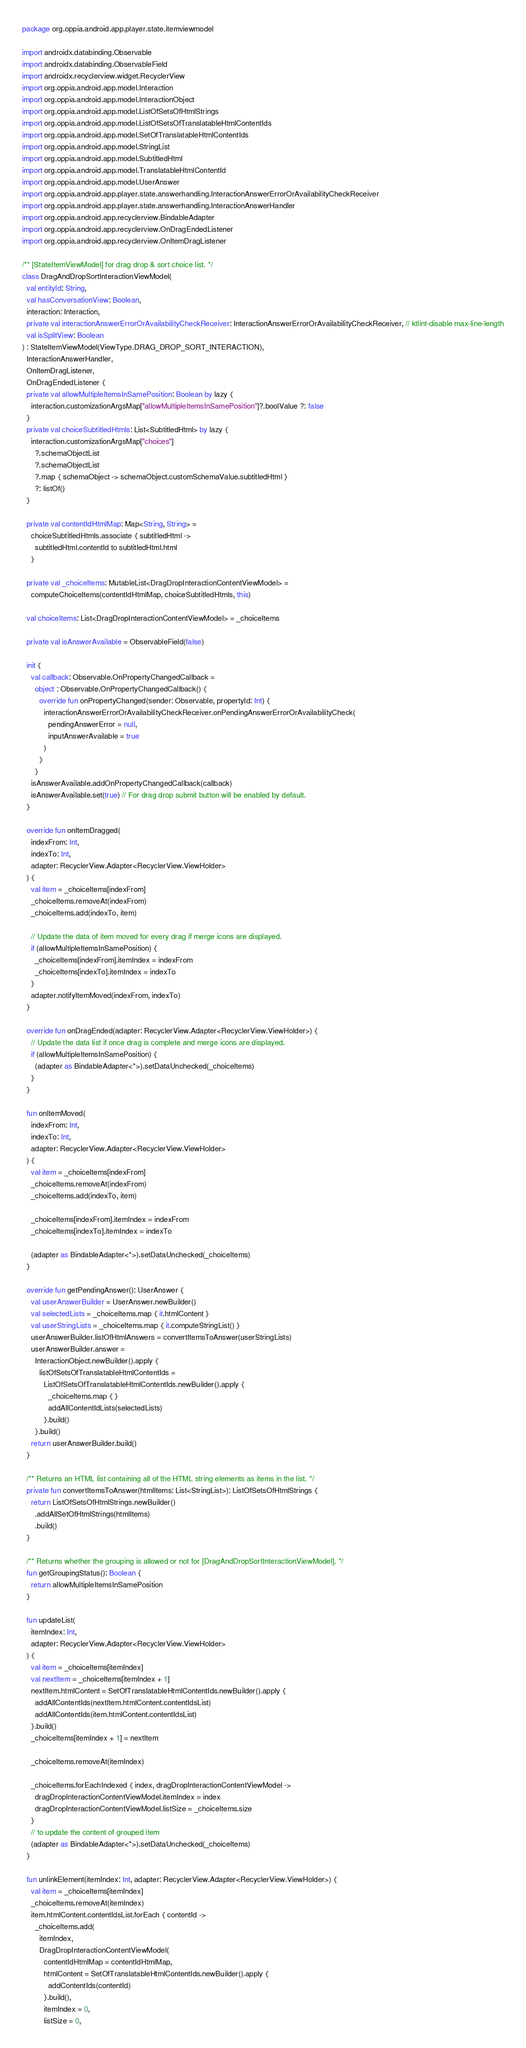Convert code to text. <code><loc_0><loc_0><loc_500><loc_500><_Kotlin_>package org.oppia.android.app.player.state.itemviewmodel

import androidx.databinding.Observable
import androidx.databinding.ObservableField
import androidx.recyclerview.widget.RecyclerView
import org.oppia.android.app.model.Interaction
import org.oppia.android.app.model.InteractionObject
import org.oppia.android.app.model.ListOfSetsOfHtmlStrings
import org.oppia.android.app.model.ListOfSetsOfTranslatableHtmlContentIds
import org.oppia.android.app.model.SetOfTranslatableHtmlContentIds
import org.oppia.android.app.model.StringList
import org.oppia.android.app.model.SubtitledHtml
import org.oppia.android.app.model.TranslatableHtmlContentId
import org.oppia.android.app.model.UserAnswer
import org.oppia.android.app.player.state.answerhandling.InteractionAnswerErrorOrAvailabilityCheckReceiver
import org.oppia.android.app.player.state.answerhandling.InteractionAnswerHandler
import org.oppia.android.app.recyclerview.BindableAdapter
import org.oppia.android.app.recyclerview.OnDragEndedListener
import org.oppia.android.app.recyclerview.OnItemDragListener

/** [StateItemViewModel] for drag drop & sort choice list. */
class DragAndDropSortInteractionViewModel(
  val entityId: String,
  val hasConversationView: Boolean,
  interaction: Interaction,
  private val interactionAnswerErrorOrAvailabilityCheckReceiver: InteractionAnswerErrorOrAvailabilityCheckReceiver, // ktlint-disable max-line-length
  val isSplitView: Boolean
) : StateItemViewModel(ViewType.DRAG_DROP_SORT_INTERACTION),
  InteractionAnswerHandler,
  OnItemDragListener,
  OnDragEndedListener {
  private val allowMultipleItemsInSamePosition: Boolean by lazy {
    interaction.customizationArgsMap["allowMultipleItemsInSamePosition"]?.boolValue ?: false
  }
  private val choiceSubtitledHtmls: List<SubtitledHtml> by lazy {
    interaction.customizationArgsMap["choices"]
      ?.schemaObjectList
      ?.schemaObjectList
      ?.map { schemaObject -> schemaObject.customSchemaValue.subtitledHtml }
      ?: listOf()
  }

  private val contentIdHtmlMap: Map<String, String> =
    choiceSubtitledHtmls.associate { subtitledHtml ->
      subtitledHtml.contentId to subtitledHtml.html
    }

  private val _choiceItems: MutableList<DragDropInteractionContentViewModel> =
    computeChoiceItems(contentIdHtmlMap, choiceSubtitledHtmls, this)

  val choiceItems: List<DragDropInteractionContentViewModel> = _choiceItems

  private val isAnswerAvailable = ObservableField(false)

  init {
    val callback: Observable.OnPropertyChangedCallback =
      object : Observable.OnPropertyChangedCallback() {
        override fun onPropertyChanged(sender: Observable, propertyId: Int) {
          interactionAnswerErrorOrAvailabilityCheckReceiver.onPendingAnswerErrorOrAvailabilityCheck(
            pendingAnswerError = null,
            inputAnswerAvailable = true
          )
        }
      }
    isAnswerAvailable.addOnPropertyChangedCallback(callback)
    isAnswerAvailable.set(true) // For drag drop submit button will be enabled by default.
  }

  override fun onItemDragged(
    indexFrom: Int,
    indexTo: Int,
    adapter: RecyclerView.Adapter<RecyclerView.ViewHolder>
  ) {
    val item = _choiceItems[indexFrom]
    _choiceItems.removeAt(indexFrom)
    _choiceItems.add(indexTo, item)

    // Update the data of item moved for every drag if merge icons are displayed.
    if (allowMultipleItemsInSamePosition) {
      _choiceItems[indexFrom].itemIndex = indexFrom
      _choiceItems[indexTo].itemIndex = indexTo
    }
    adapter.notifyItemMoved(indexFrom, indexTo)
  }

  override fun onDragEnded(adapter: RecyclerView.Adapter<RecyclerView.ViewHolder>) {
    // Update the data list if once drag is complete and merge icons are displayed.
    if (allowMultipleItemsInSamePosition) {
      (adapter as BindableAdapter<*>).setDataUnchecked(_choiceItems)
    }
  }

  fun onItemMoved(
    indexFrom: Int,
    indexTo: Int,
    adapter: RecyclerView.Adapter<RecyclerView.ViewHolder>
  ) {
    val item = _choiceItems[indexFrom]
    _choiceItems.removeAt(indexFrom)
    _choiceItems.add(indexTo, item)

    _choiceItems[indexFrom].itemIndex = indexFrom
    _choiceItems[indexTo].itemIndex = indexTo

    (adapter as BindableAdapter<*>).setDataUnchecked(_choiceItems)
  }

  override fun getPendingAnswer(): UserAnswer {
    val userAnswerBuilder = UserAnswer.newBuilder()
    val selectedLists = _choiceItems.map { it.htmlContent }
    val userStringLists = _choiceItems.map { it.computeStringList() }
    userAnswerBuilder.listOfHtmlAnswers = convertItemsToAnswer(userStringLists)
    userAnswerBuilder.answer =
      InteractionObject.newBuilder().apply {
        listOfSetsOfTranslatableHtmlContentIds =
          ListOfSetsOfTranslatableHtmlContentIds.newBuilder().apply {
            _choiceItems.map { }
            addAllContentIdLists(selectedLists)
          }.build()
      }.build()
    return userAnswerBuilder.build()
  }

  /** Returns an HTML list containing all of the HTML string elements as items in the list. */
  private fun convertItemsToAnswer(htmlItems: List<StringList>): ListOfSetsOfHtmlStrings {
    return ListOfSetsOfHtmlStrings.newBuilder()
      .addAllSetOfHtmlStrings(htmlItems)
      .build()
  }

  /** Returns whether the grouping is allowed or not for [DragAndDropSortInteractionViewModel]. */
  fun getGroupingStatus(): Boolean {
    return allowMultipleItemsInSamePosition
  }

  fun updateList(
    itemIndex: Int,
    adapter: RecyclerView.Adapter<RecyclerView.ViewHolder>
  ) {
    val item = _choiceItems[itemIndex]
    val nextItem = _choiceItems[itemIndex + 1]
    nextItem.htmlContent = SetOfTranslatableHtmlContentIds.newBuilder().apply {
      addAllContentIds(nextItem.htmlContent.contentIdsList)
      addAllContentIds(item.htmlContent.contentIdsList)
    }.build()
    _choiceItems[itemIndex + 1] = nextItem

    _choiceItems.removeAt(itemIndex)

    _choiceItems.forEachIndexed { index, dragDropInteractionContentViewModel ->
      dragDropInteractionContentViewModel.itemIndex = index
      dragDropInteractionContentViewModel.listSize = _choiceItems.size
    }
    // to update the content of grouped item
    (adapter as BindableAdapter<*>).setDataUnchecked(_choiceItems)
  }

  fun unlinkElement(itemIndex: Int, adapter: RecyclerView.Adapter<RecyclerView.ViewHolder>) {
    val item = _choiceItems[itemIndex]
    _choiceItems.removeAt(itemIndex)
    item.htmlContent.contentIdsList.forEach { contentId ->
      _choiceItems.add(
        itemIndex,
        DragDropInteractionContentViewModel(
          contentIdHtmlMap = contentIdHtmlMap,
          htmlContent = SetOfTranslatableHtmlContentIds.newBuilder().apply {
            addContentIds(contentId)
          }.build(),
          itemIndex = 0,
          listSize = 0,</code> 